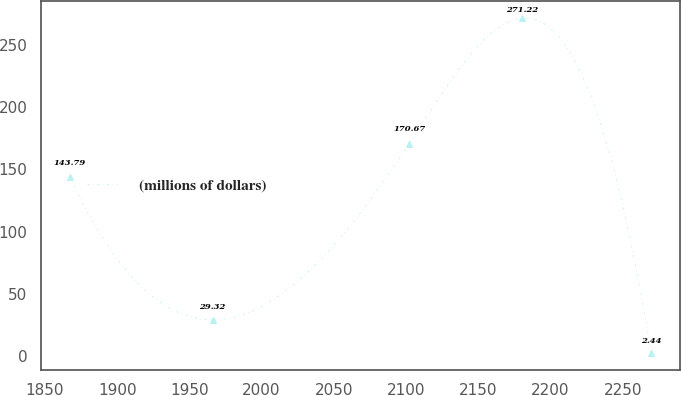Convert chart. <chart><loc_0><loc_0><loc_500><loc_500><line_chart><ecel><fcel>(millions of dollars)<nl><fcel>1867.24<fcel>143.79<nl><fcel>1966.12<fcel>29.32<nl><fcel>2102.26<fcel>170.67<nl><fcel>2180.39<fcel>271.22<nl><fcel>2269.8<fcel>2.44<nl></chart> 